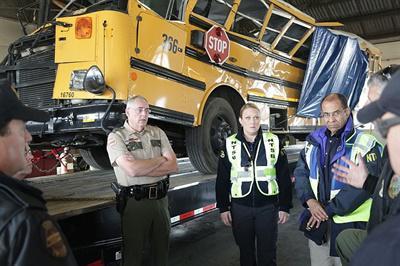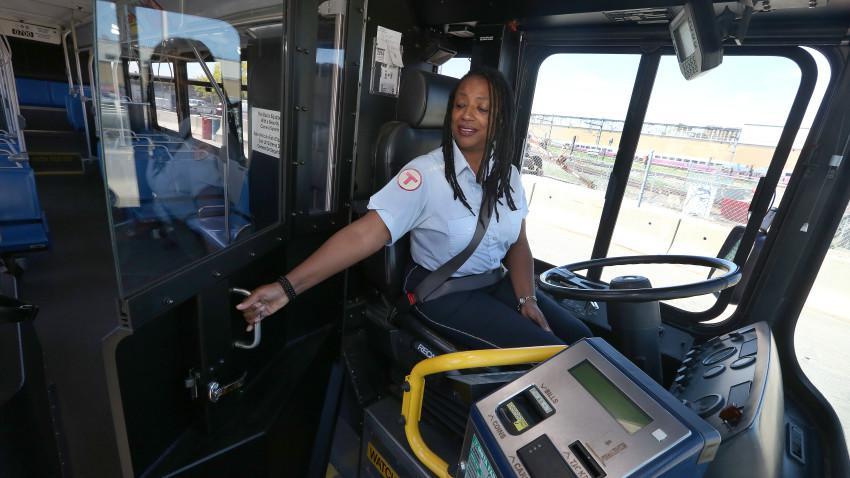The first image is the image on the left, the second image is the image on the right. For the images displayed, is the sentence "One image shows a blue tarp covering part of the crumpled side of a yellow bus." factually correct? Answer yes or no. Yes. The first image is the image on the left, the second image is the image on the right. Evaluate the accuracy of this statement regarding the images: "A severely damaged school bus has a blue tarp hanging down the side.". Is it true? Answer yes or no. Yes. 